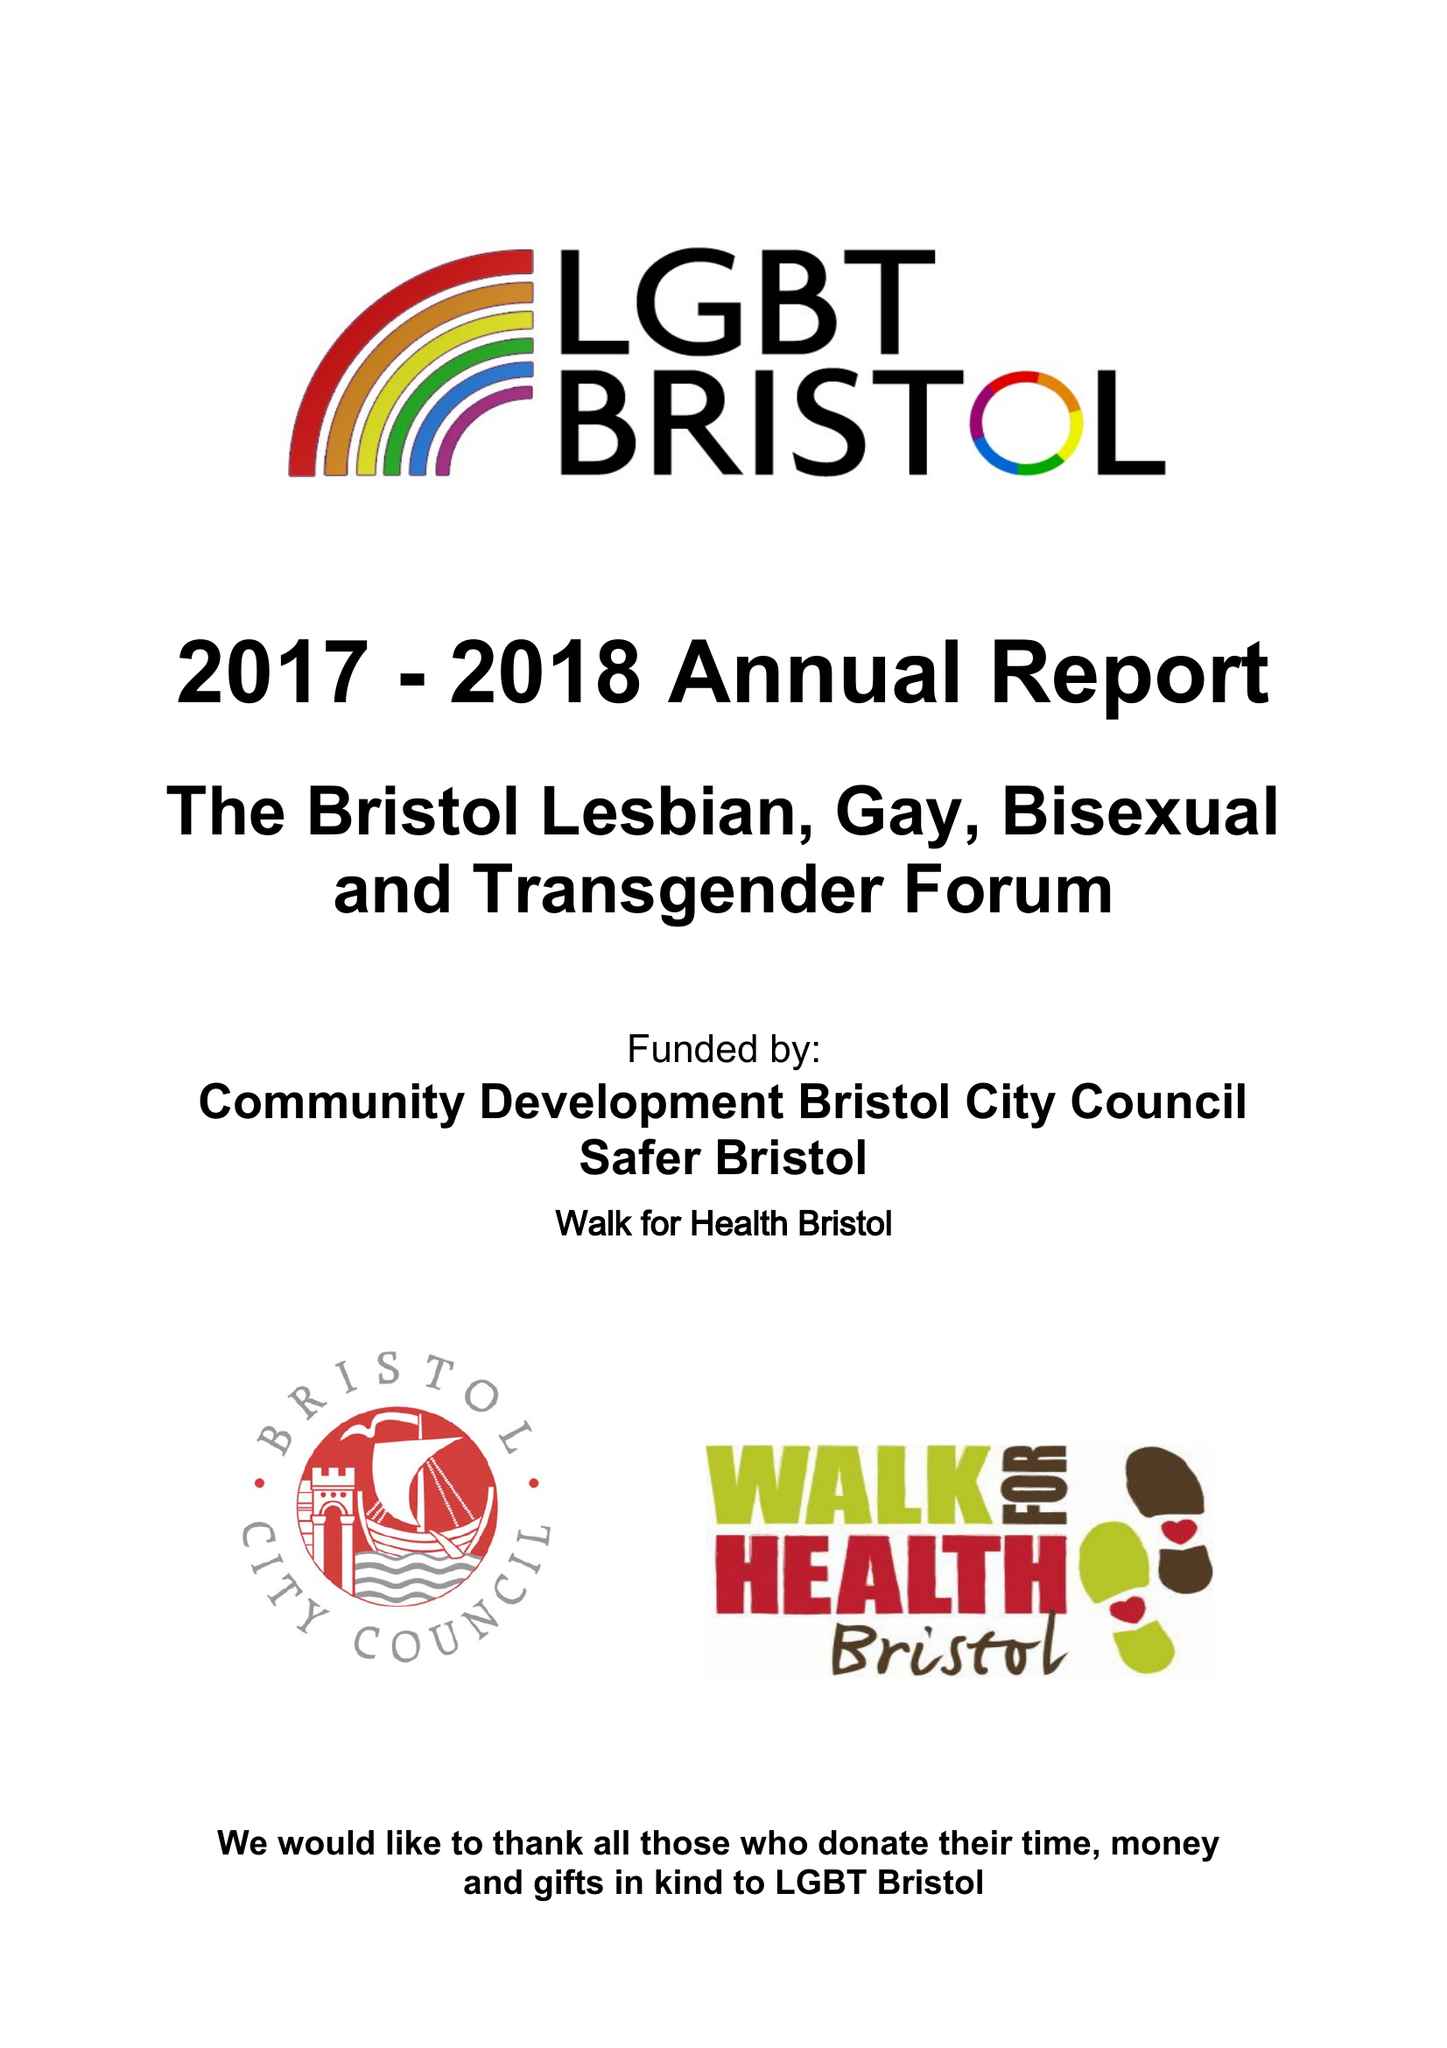What is the value for the charity_number?
Answer the question using a single word or phrase. 1098085 